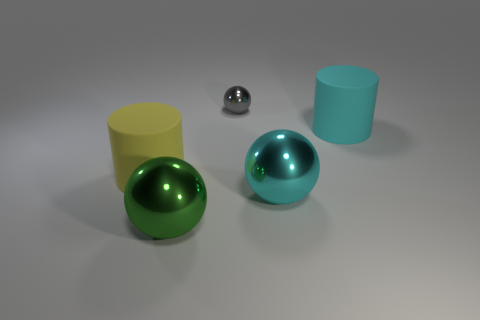Is there anything else that has the same size as the gray metal object?
Make the answer very short. No. Does the small gray metallic object have the same shape as the yellow matte object?
Provide a short and direct response. No. There is a rubber cylinder that is to the right of the cyan metal sphere that is to the right of the gray metal ball; how big is it?
Give a very brief answer. Large. There is another matte thing that is the same shape as the large cyan rubber object; what is its color?
Your response must be concise. Yellow. The gray ball has what size?
Make the answer very short. Small. Do the green ball and the gray object have the same size?
Your answer should be very brief. No. What color is the large object that is on the left side of the cyan metallic thing and to the right of the big yellow matte thing?
Keep it short and to the point. Green. What number of green spheres are made of the same material as the green thing?
Keep it short and to the point. 0. What number of cyan rubber spheres are there?
Provide a succinct answer. 0. There is a green metal thing; is it the same size as the cylinder behind the large yellow cylinder?
Make the answer very short. Yes. 